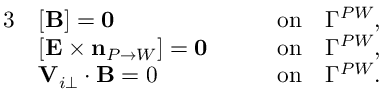<formula> <loc_0><loc_0><loc_500><loc_500>\begin{array} { r l r } { 3 } & { [ { \mathbf B } ] = 0 \quad } & { o n \quad \Gamma ^ { P W } , } \\ & { [ { \mathbf E } \times n _ { P \rightarrow W } ] = 0 \quad } & { o n \quad \Gamma ^ { P W } , } \\ & { \mathbf V _ { i \perp } \cdot \mathbf B = 0 \quad } & { o n \quad \Gamma ^ { P W } . } \end{array}</formula> 